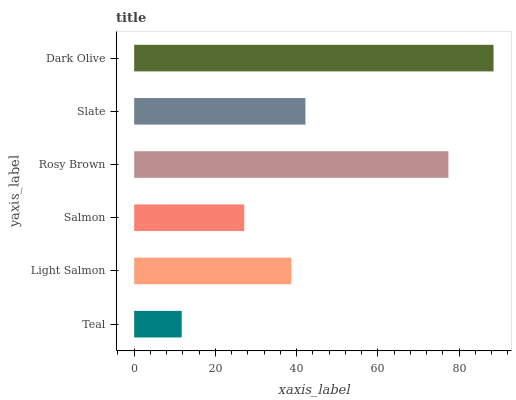Is Teal the minimum?
Answer yes or no. Yes. Is Dark Olive the maximum?
Answer yes or no. Yes. Is Light Salmon the minimum?
Answer yes or no. No. Is Light Salmon the maximum?
Answer yes or no. No. Is Light Salmon greater than Teal?
Answer yes or no. Yes. Is Teal less than Light Salmon?
Answer yes or no. Yes. Is Teal greater than Light Salmon?
Answer yes or no. No. Is Light Salmon less than Teal?
Answer yes or no. No. Is Slate the high median?
Answer yes or no. Yes. Is Light Salmon the low median?
Answer yes or no. Yes. Is Salmon the high median?
Answer yes or no. No. Is Rosy Brown the low median?
Answer yes or no. No. 